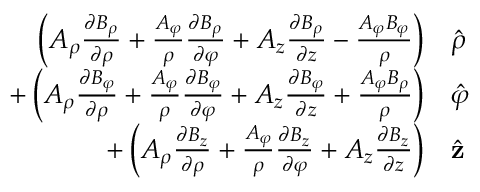Convert formula to latex. <formula><loc_0><loc_0><loc_500><loc_500>{ \begin{array} { r l } { \left ( A _ { \rho } { \frac { \partial B _ { \rho } } { \partial \rho } } + { \frac { A _ { \varphi } } { \rho } } { \frac { \partial B _ { \rho } } { \partial \varphi } } + A _ { z } { \frac { \partial B _ { \rho } } { \partial z } } - { \frac { A _ { \varphi } B _ { \varphi } } { \rho } } \right ) } & { { \hat { \rho } } } \\ { + \left ( A _ { \rho } { \frac { \partial B _ { \varphi } } { \partial \rho } } + { \frac { A _ { \varphi } } { \rho } } { \frac { \partial B _ { \varphi } } { \partial \varphi } } + A _ { z } { \frac { \partial B _ { \varphi } } { \partial z } } + { \frac { A _ { \varphi } B _ { \rho } } { \rho } } \right ) } & { { \hat { \varphi } } } \\ { + \left ( A _ { \rho } { \frac { \partial B _ { z } } { \partial \rho } } + { \frac { A _ { \varphi } } { \rho } } { \frac { \partial B _ { z } } { \partial \varphi } } + A _ { z } { \frac { \partial B _ { z } } { \partial z } } \right ) } & { { \hat { z } } } \end{array} }</formula> 